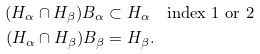Convert formula to latex. <formula><loc_0><loc_0><loc_500><loc_500>( H _ { \alpha } \cap H _ { \beta } ) B _ { \alpha } & \subset H _ { \alpha } \quad \text {index $1$ or $2$} \\ ( H _ { \alpha } \cap H _ { \beta } ) B _ { \beta } & = H _ { \beta } .</formula> 